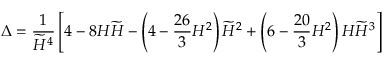<formula> <loc_0><loc_0><loc_500><loc_500>\Delta = \frac { 1 } { \widetilde { H } ^ { 4 } } \left [ 4 - 8 H \widetilde { H } - \left ( 4 - \frac { 2 6 } { 3 } H ^ { 2 } \right ) \widetilde { H } ^ { 2 } + \left ( 6 - \frac { 2 0 } { 3 } H ^ { 2 } \right ) H \widetilde { H } ^ { 3 } \right ]</formula> 